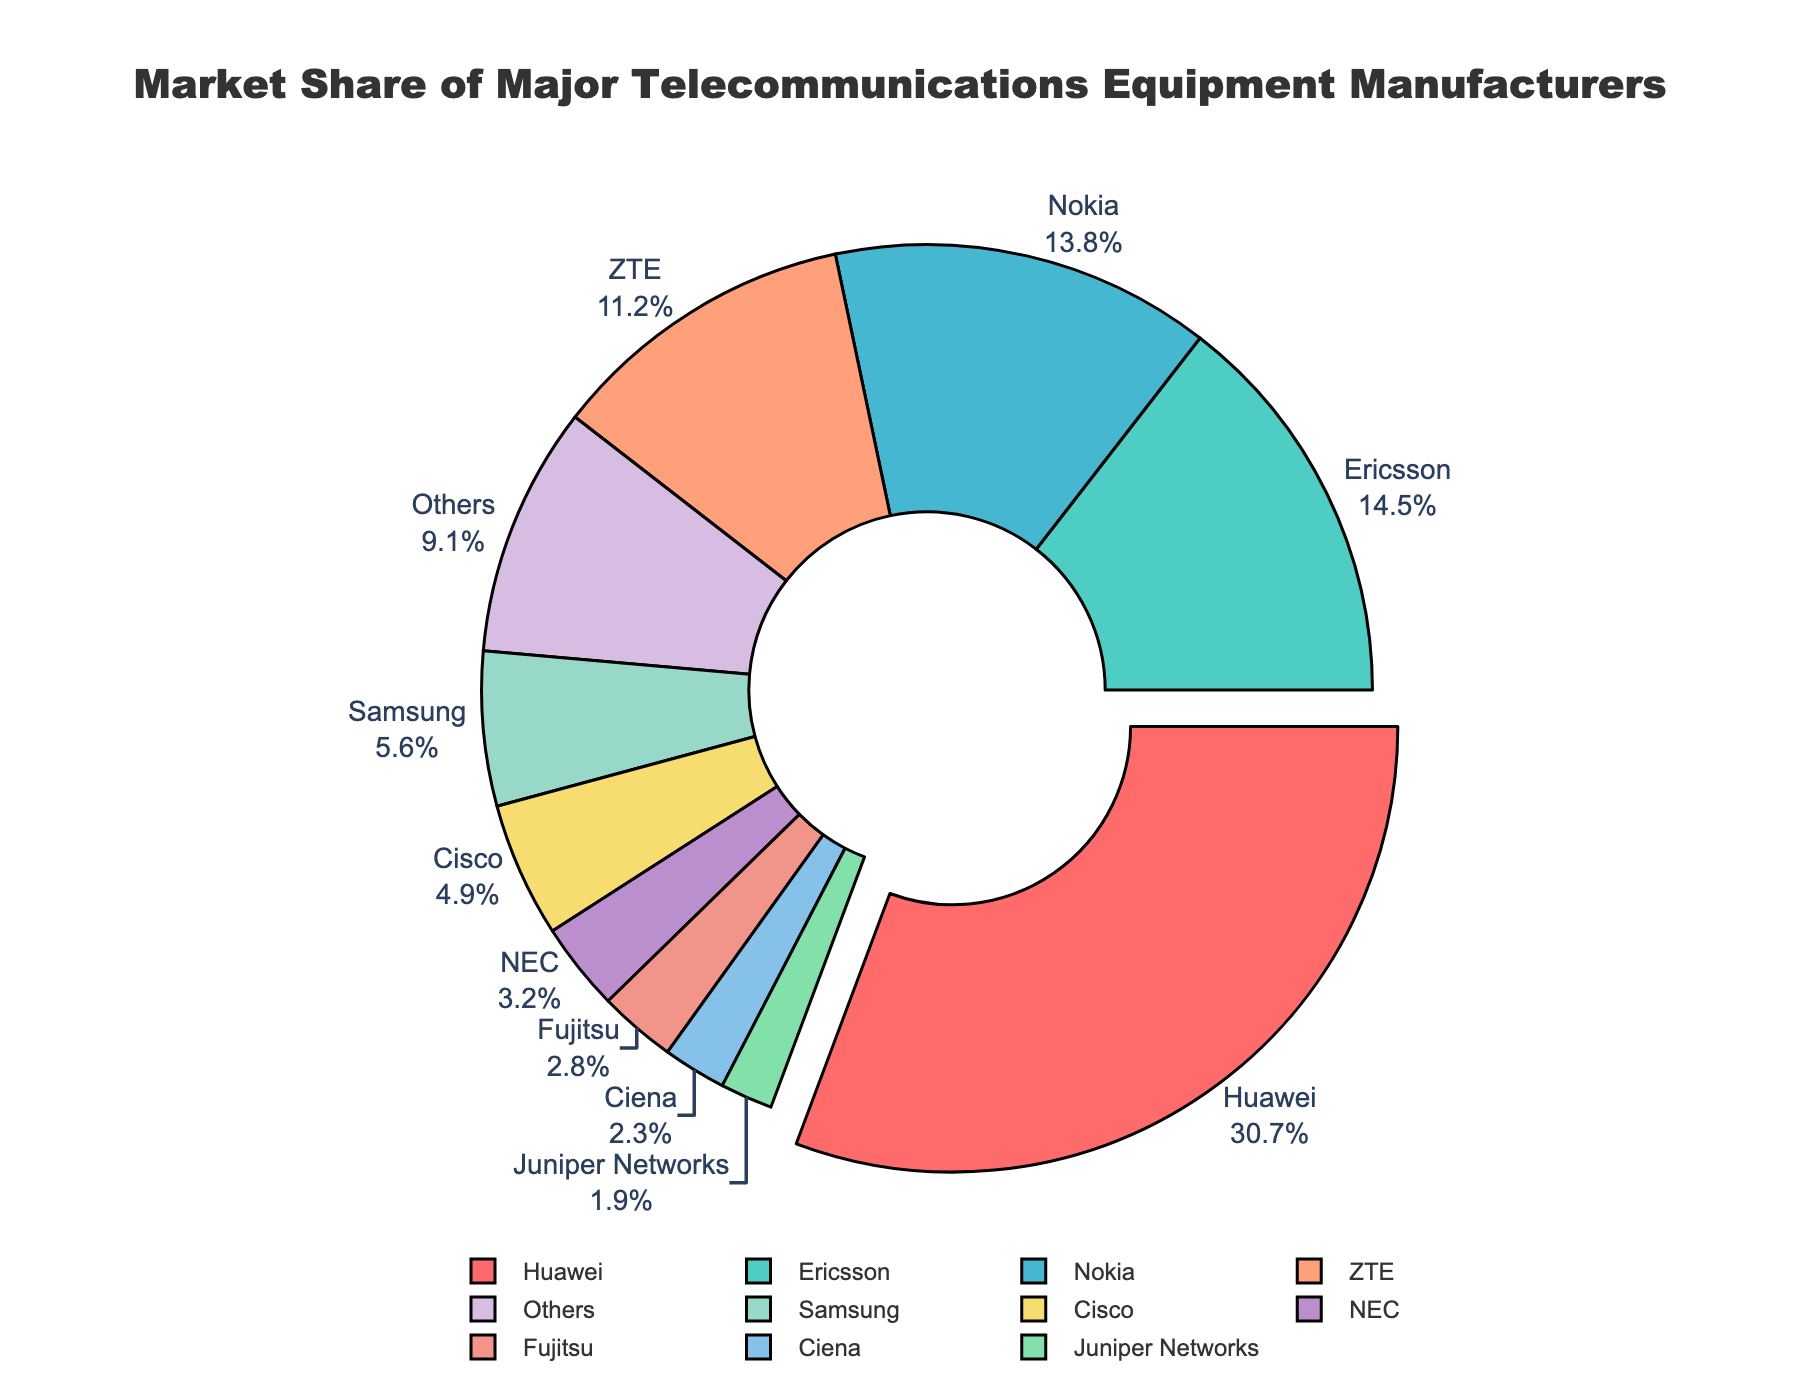Which company has the largest market share? The pie chart highlights the company with the largest market share by pulling its segment outward. This visually indicates Huawei as having the largest segment.
Answer: Huawei What is the combined market share of Ericsson and Nokia? Look for the market share values of Ericsson and Nokia on the pie chart. Ericsson has 14.5% and Nokia has 13.8%. Adding them together gives 14.5 + 13.8.
Answer: 28.3% Which company has a larger market share: ZTE or Samsung? Compare the market share percentages for ZTE and Samsung shown on the pie chart. ZTE has 11.2% while Samsung has 5.6%.
Answer: ZTE What is the total market share of companies with less than 5% market share? Identify the companies with less than 5% market share from the chart: Cisco (4.9%), NEC (3.2%), Fujitsu (2.8%), Ciena (2.3%), Juniper Networks (1.9%). Sum these values: 4.9 + 3.2 + 2.8 + 2.3 + 1.9.
Answer: 15.1% What is the difference in market share between Huawei and the next largest company? Note that Huawei has the largest market share at 30.7%. The next largest is Ericsson at 14.5%. Subtract Ericsson's share from Huawei's: 30.7 - 14.5.
Answer: 16.2% Which section of the pie chart is represented using the blue color? The pie chart uses a specific color scheme. Locate the section of the chart that is colored blue to identify the corresponding company.
Answer: Nokia How many companies individually contribute more than 10% to the market share? From the pie chart, identify the companies with market shares greater than 10%: Huawei (30.7%), Ericsson (14.5%), Nokia (13.8%), ZTE (11.2%). Count these companies.
Answer: 4 What is the average market share of Samsung, Cisco, and NEC? Find the market share percentages for Samsung (5.6%), Cisco (4.9%), and NEC (3.2%). Sum these values and divide by 3 to get the average: (5.6 + 4.9 + 3.2) / 3.
Answer: 4.57% How much more market share does Fujitsu need to catch up with ZTE? ZTE has a market share of 11.2%, and Fujitsu has 2.8%. Subtract Fujitsu's share from ZTE's: 11.2 - 2.8.
Answer: 8.4% What is the total market share represented by the "Others" category and companies with less than 3% share? "Others" represents 9.1%. Additionally, identify companies with less than 3% share: Fujitsu (2.8%), Ciena (2.3%), and Juniper Networks (1.9%). Sum these values: 9.1 + 2.8 + 2.3 + 1.9.
Answer: 16.1% 